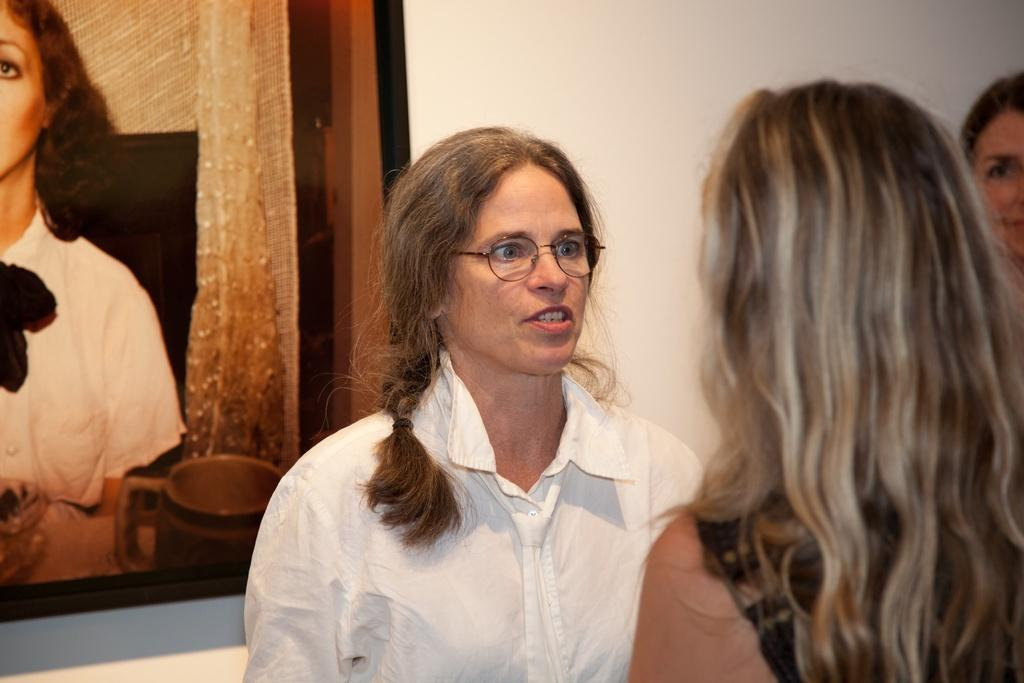Where are the women located in the image? The women are in the foreground of the image, on the right side. What can be seen on the left side of the image? There is a frame on the wall on the left side of the image. What type of loss is depicted in the image? There is no depiction of loss in the image; it features women in the foreground and a frame on the wall. What tool is used to hammer the frame into the wall in the image? There is no hammer or any indication of the frame being attached to the wall in the image. 